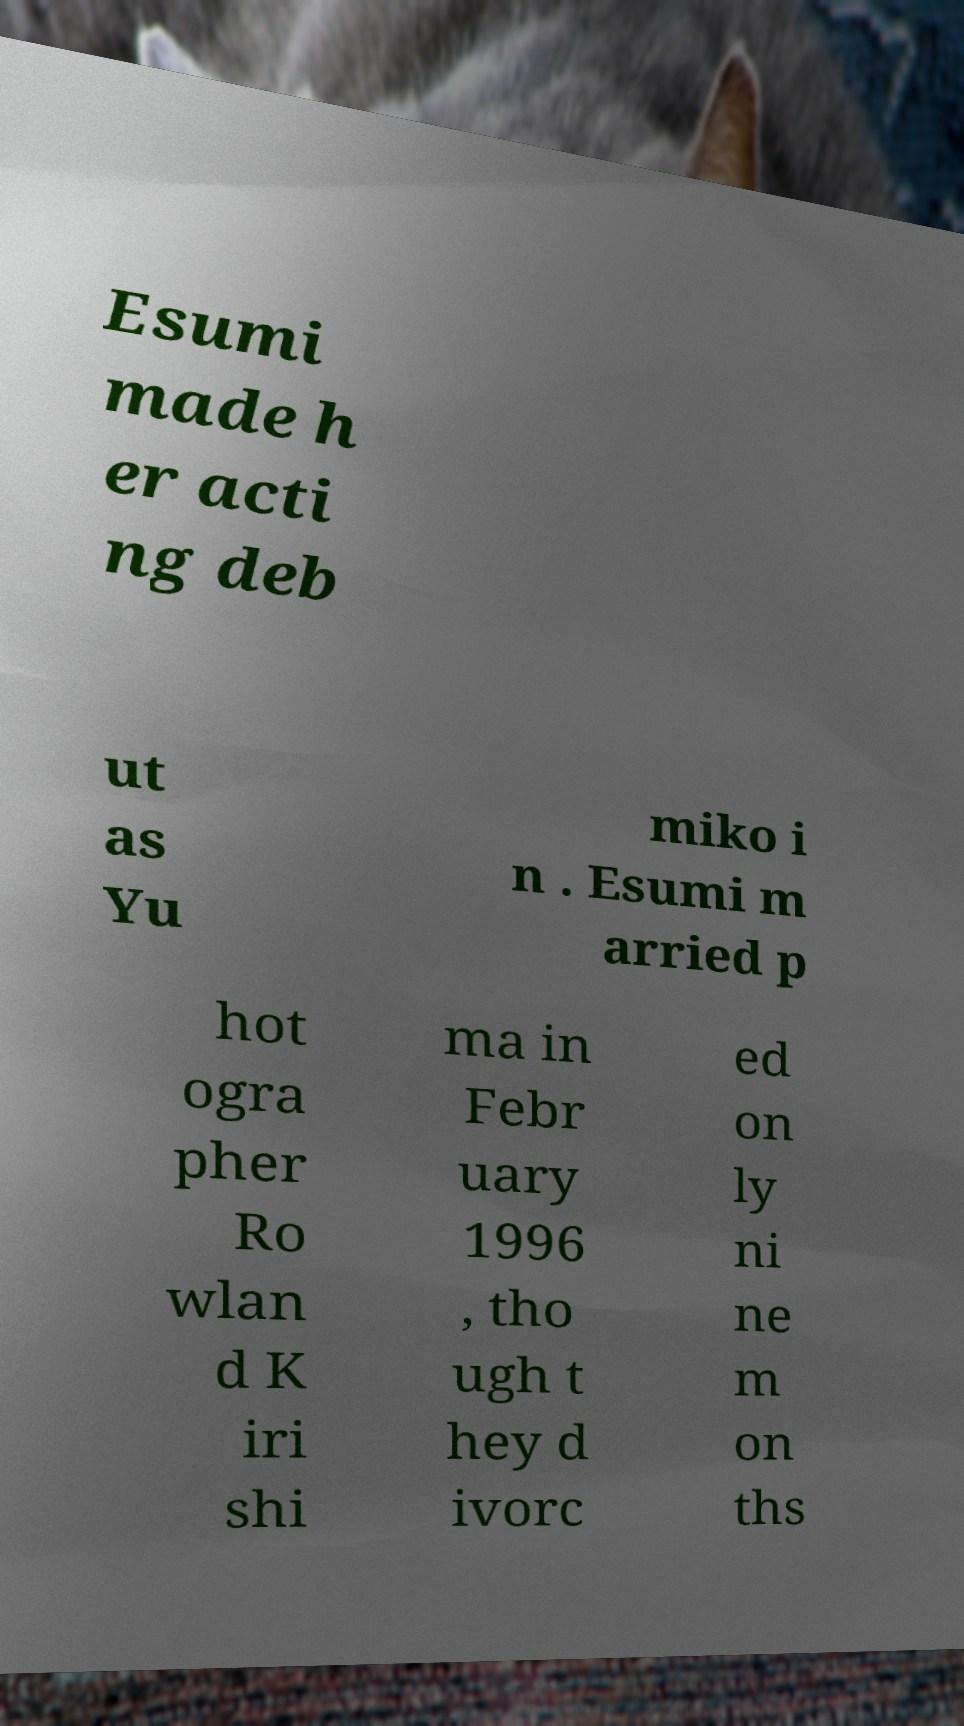Could you assist in decoding the text presented in this image and type it out clearly? Esumi made h er acti ng deb ut as Yu miko i n . Esumi m arried p hot ogra pher Ro wlan d K iri shi ma in Febr uary 1996 , tho ugh t hey d ivorc ed on ly ni ne m on ths 